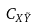Convert formula to latex. <formula><loc_0><loc_0><loc_500><loc_500>C _ { X \tilde { Y } }</formula> 